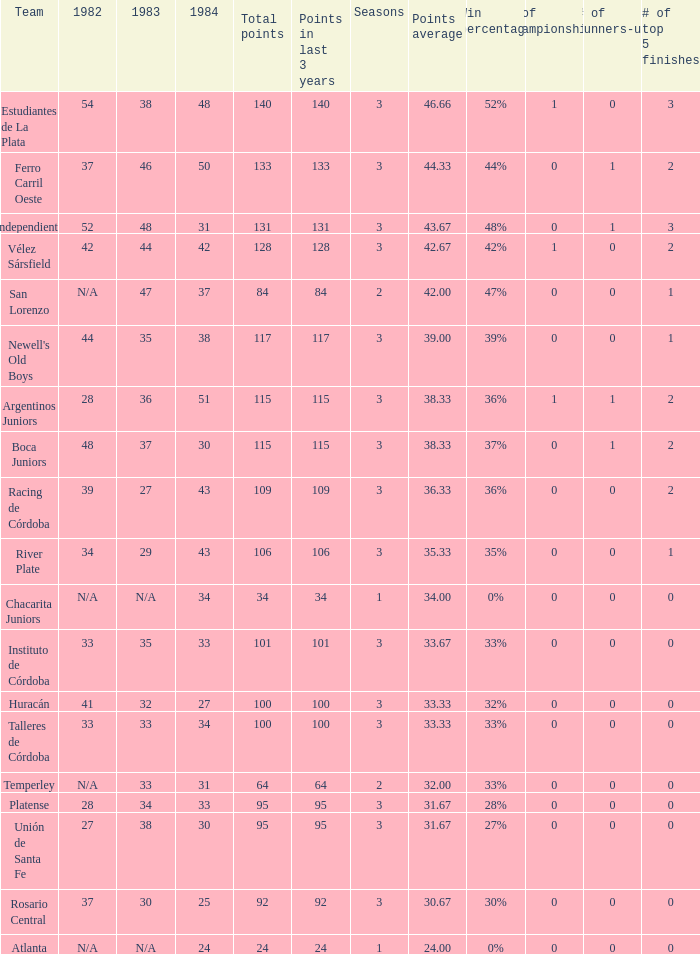What is the number of seasons for the team with a total fewer than 24? None. 